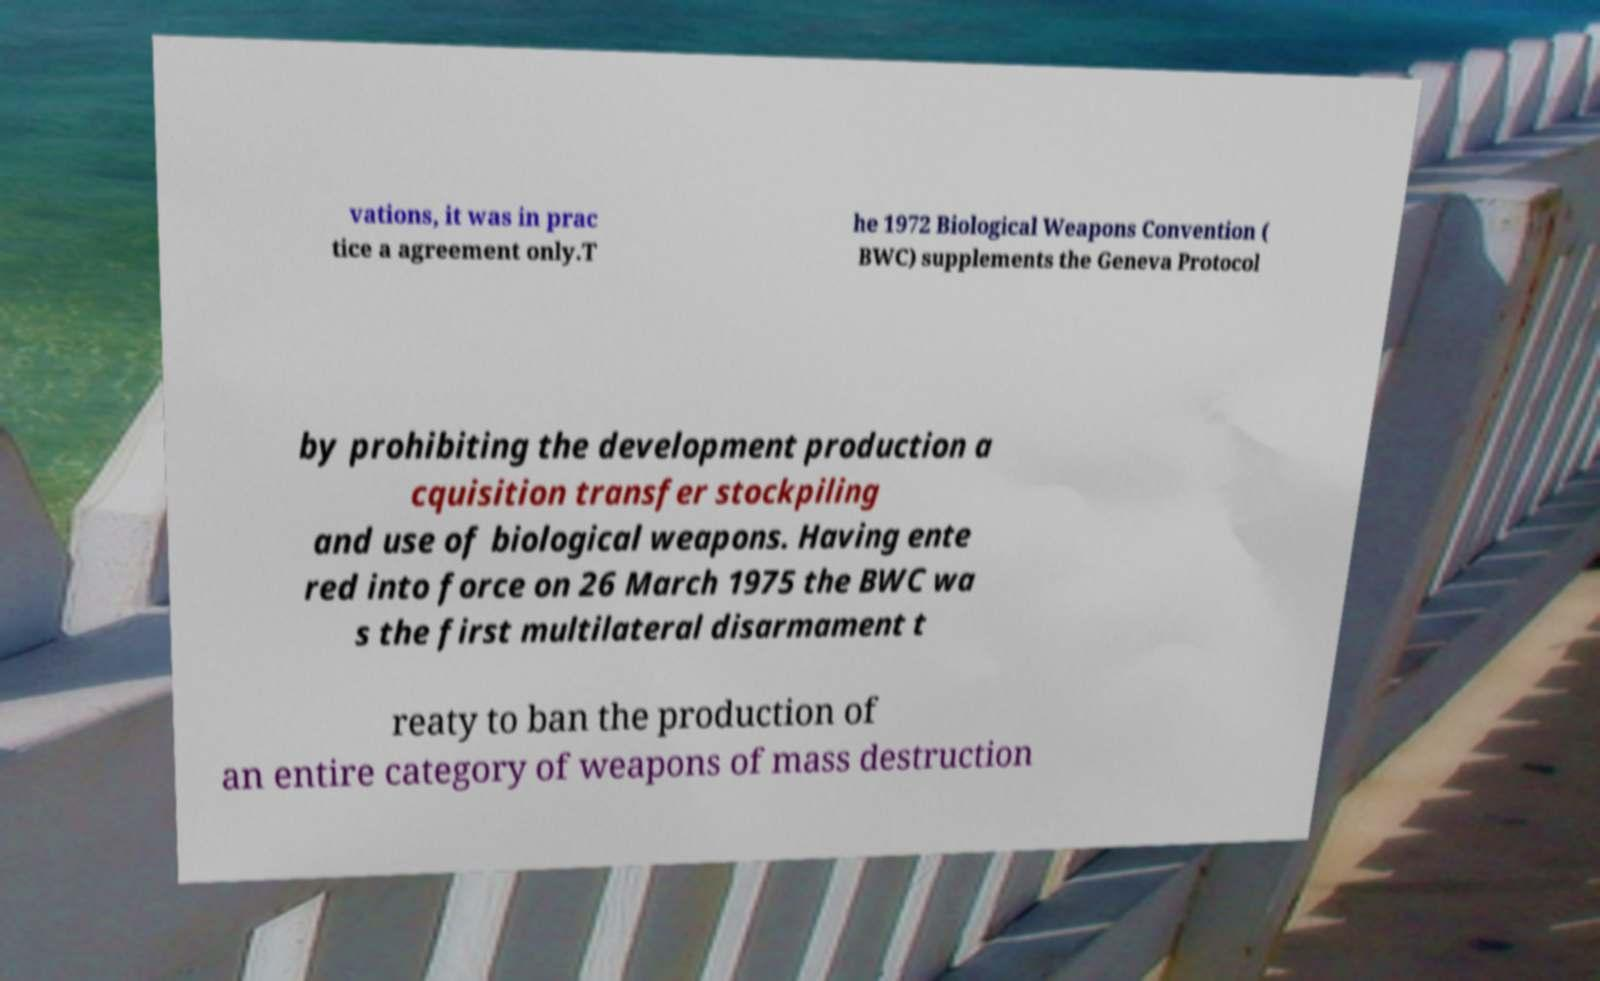Please identify and transcribe the text found in this image. vations, it was in prac tice a agreement only.T he 1972 Biological Weapons Convention ( BWC) supplements the Geneva Protocol by prohibiting the development production a cquisition transfer stockpiling and use of biological weapons. Having ente red into force on 26 March 1975 the BWC wa s the first multilateral disarmament t reaty to ban the production of an entire category of weapons of mass destruction 